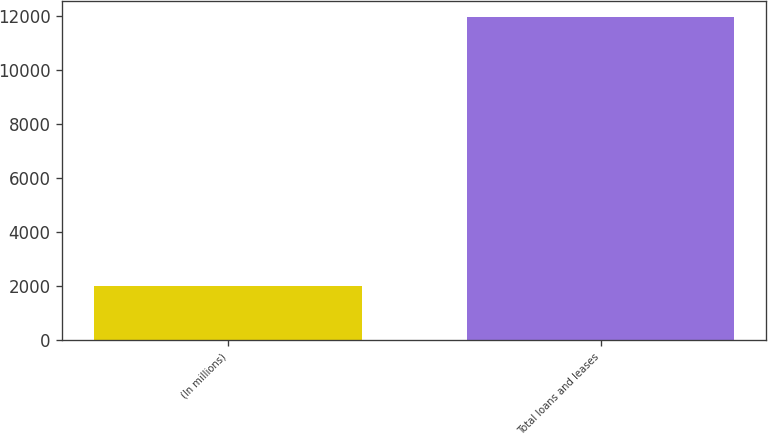Convert chart. <chart><loc_0><loc_0><loc_500><loc_500><bar_chart><fcel>(In millions)<fcel>Total loans and leases<nl><fcel>2010<fcel>11957<nl></chart> 